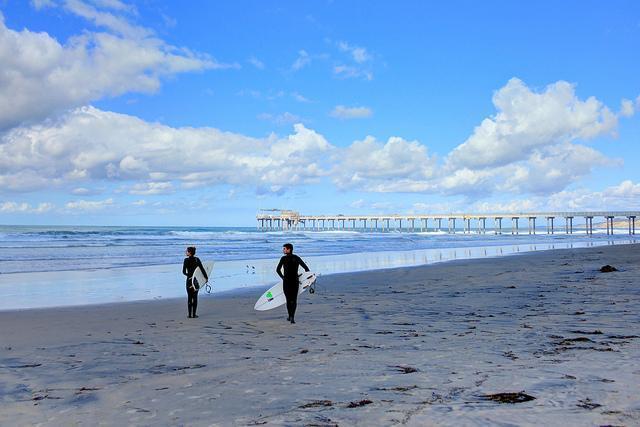How many people are standing near the water?
Give a very brief answer. 2. How many people are holding a surfboard?
Give a very brief answer. 2. How many cones are there?
Give a very brief answer. 0. How many legs do the animals have?
Give a very brief answer. 2. How many people are wearing orange shirts?
Give a very brief answer. 0. 